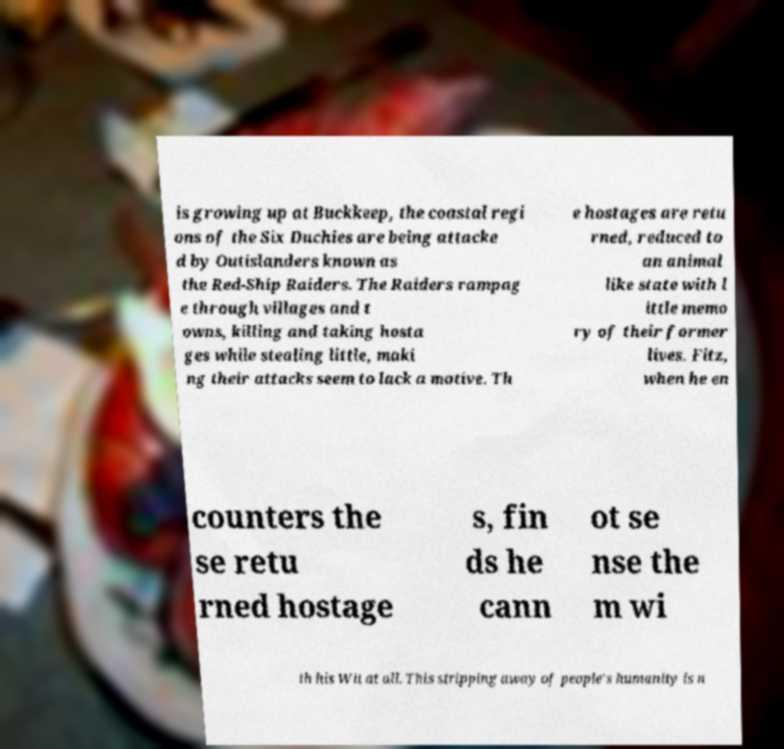Please identify and transcribe the text found in this image. is growing up at Buckkeep, the coastal regi ons of the Six Duchies are being attacke d by Outislanders known as the Red-Ship Raiders. The Raiders rampag e through villages and t owns, killing and taking hosta ges while stealing little, maki ng their attacks seem to lack a motive. Th e hostages are retu rned, reduced to an animal like state with l ittle memo ry of their former lives. Fitz, when he en counters the se retu rned hostage s, fin ds he cann ot se nse the m wi th his Wit at all. This stripping away of people's humanity is n 